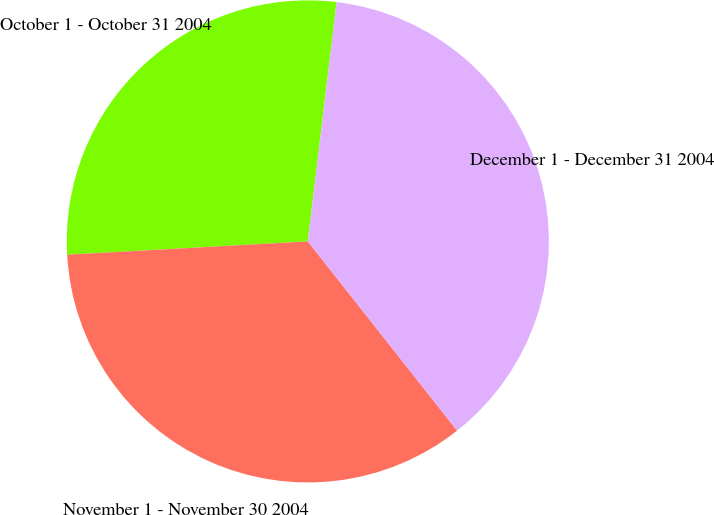Convert chart. <chart><loc_0><loc_0><loc_500><loc_500><pie_chart><fcel>October 1 - October 31 2004<fcel>November 1 - November 30 2004<fcel>December 1 - December 31 2004<nl><fcel>27.79%<fcel>34.75%<fcel>37.46%<nl></chart> 